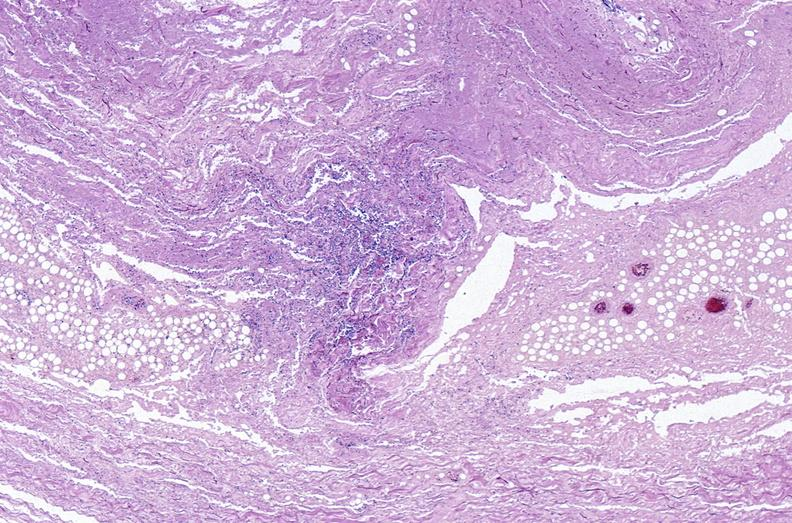does this image show panniculitis and fascitis?
Answer the question using a single word or phrase. Yes 